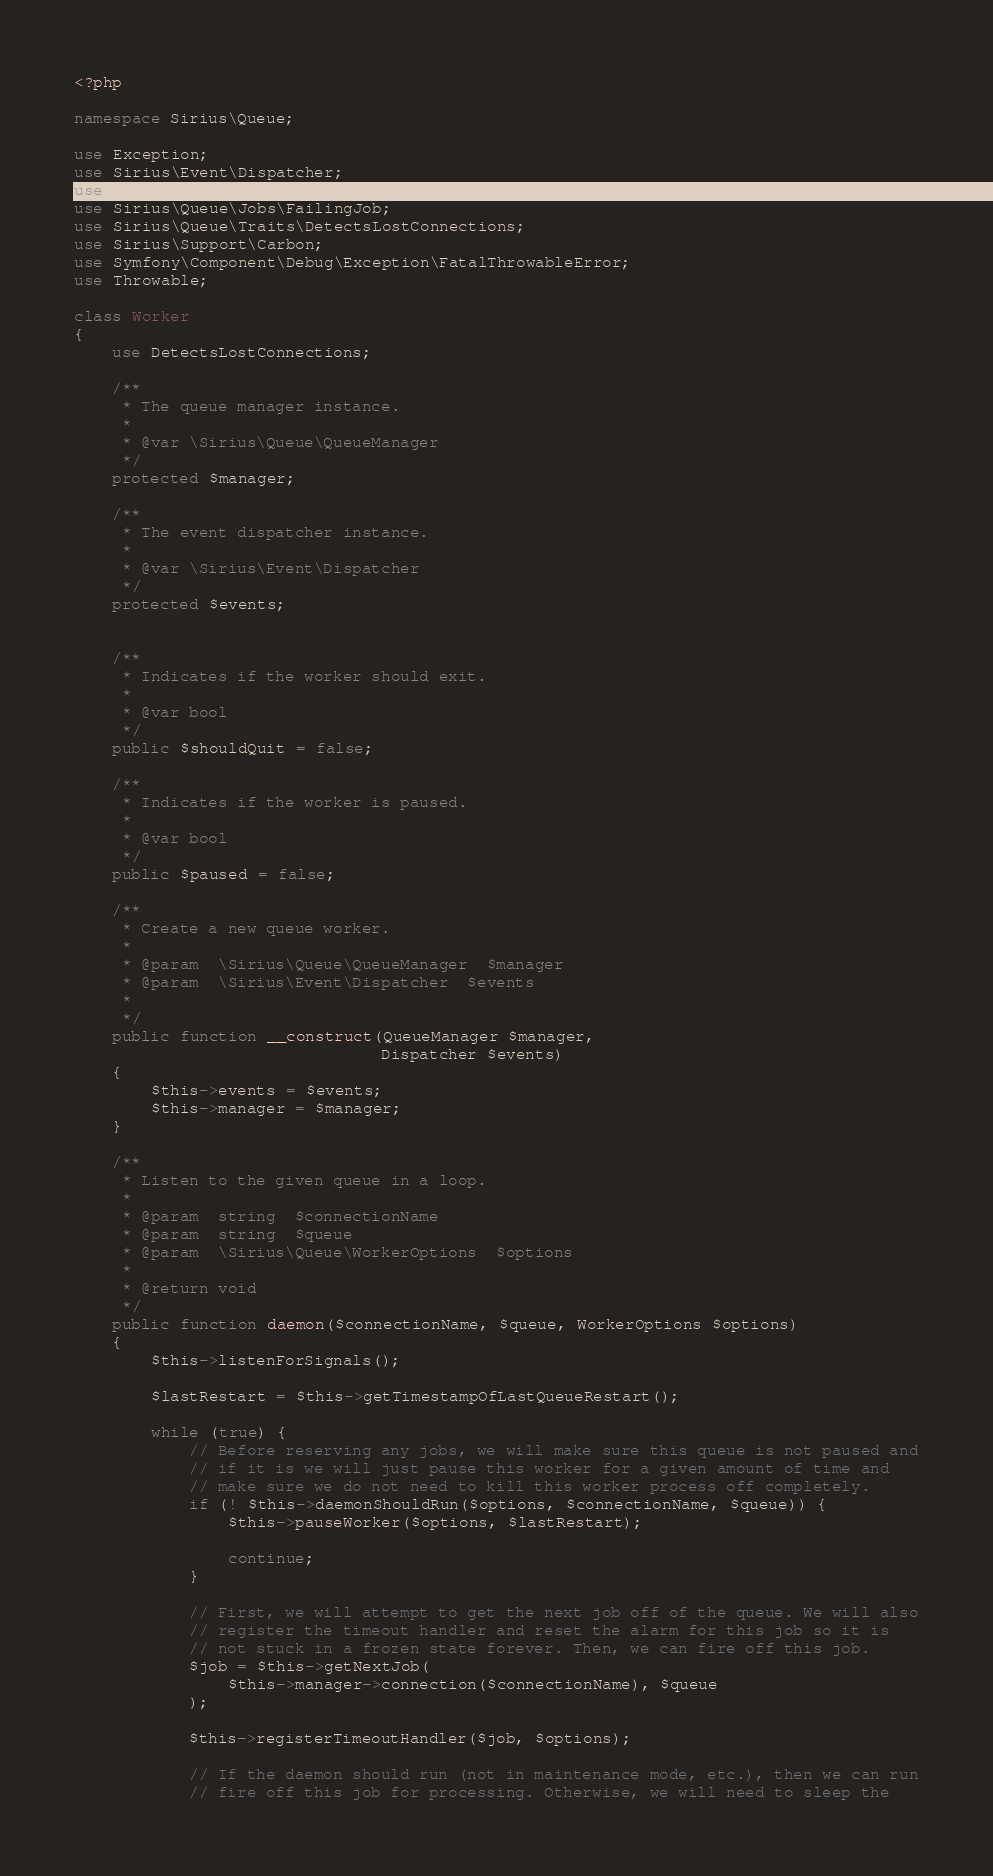Convert code to text. <code><loc_0><loc_0><loc_500><loc_500><_PHP_><?php

namespace Sirius\Queue;

use Exception;
use Sirius\Event\Dispatcher;
use Sirius\Queue\Exceptions\ManuallyFailedException;
use Sirius\Queue\Jobs\FailingJob;
use Sirius\Queue\Traits\DetectsLostConnections;
use Sirius\Support\Carbon;
use Symfony\Component\Debug\Exception\FatalThrowableError;
use Throwable;

class Worker
{
    use DetectsLostConnections;

    /**
     * The queue manager instance.
     *
     * @var \Sirius\Queue\QueueManager
     */
    protected $manager;

    /**
     * The event dispatcher instance.
     *
     * @var \Sirius\Event\Dispatcher
     */
    protected $events;


    /**
     * Indicates if the worker should exit.
     *
     * @var bool
     */
    public $shouldQuit = false;

    /**
     * Indicates if the worker is paused.
     *
     * @var bool
     */
    public $paused = false;

    /**
     * Create a new queue worker.
     *
     * @param  \Sirius\Queue\QueueManager  $manager
     * @param  \Sirius\Event\Dispatcher  $events
     *
     */
    public function __construct(QueueManager $manager,
                                Dispatcher $events)
    {
        $this->events = $events;
        $this->manager = $manager;
    }

    /**
     * Listen to the given queue in a loop.
     *
     * @param  string  $connectionName
     * @param  string  $queue
     * @param  \Sirius\Queue\WorkerOptions  $options
     *
     * @return void
     */
    public function daemon($connectionName, $queue, WorkerOptions $options)
    {
        $this->listenForSignals();

        $lastRestart = $this->getTimestampOfLastQueueRestart();

        while (true) {
            // Before reserving any jobs, we will make sure this queue is not paused and
            // if it is we will just pause this worker for a given amount of time and
            // make sure we do not need to kill this worker process off completely.
            if (! $this->daemonShouldRun($options, $connectionName, $queue)) {
                $this->pauseWorker($options, $lastRestart);

                continue;
            }

            // First, we will attempt to get the next job off of the queue. We will also
            // register the timeout handler and reset the alarm for this job so it is
            // not stuck in a frozen state forever. Then, we can fire off this job.
            $job = $this->getNextJob(
                $this->manager->connection($connectionName), $queue
            );

            $this->registerTimeoutHandler($job, $options);

            // If the daemon should run (not in maintenance mode, etc.), then we can run
            // fire off this job for processing. Otherwise, we will need to sleep the</code> 